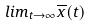Convert formula to latex. <formula><loc_0><loc_0><loc_500><loc_500>l i m _ { t \rightarrow \infty } \overline { x } ( t )</formula> 